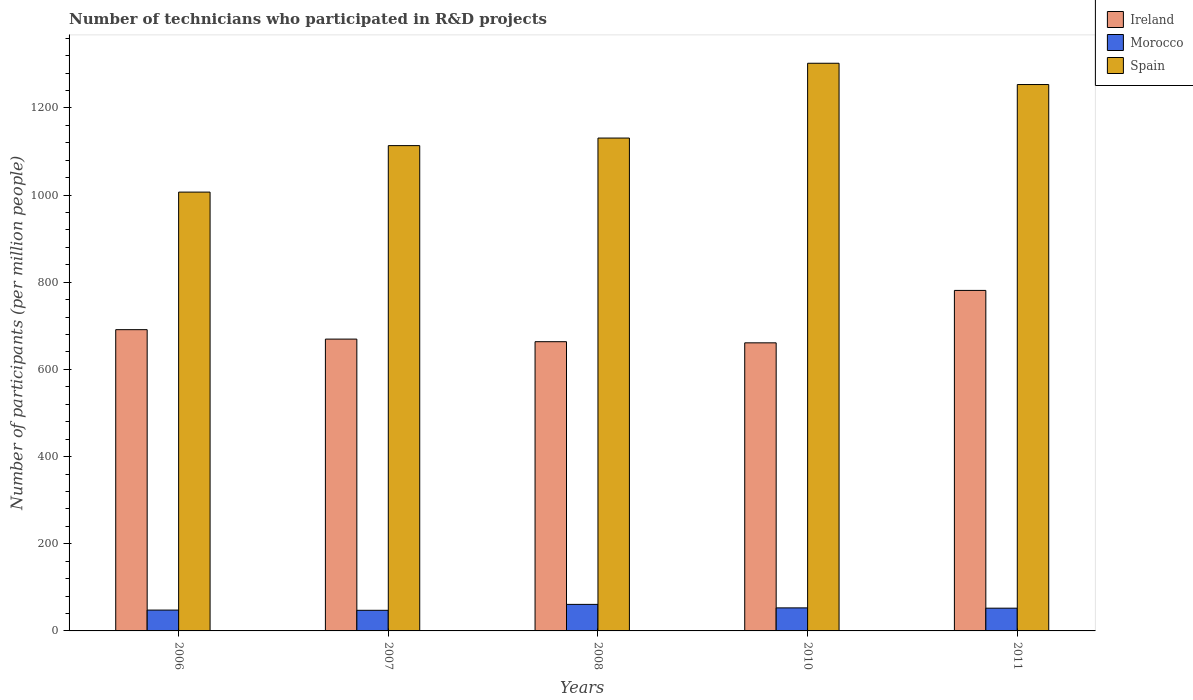How many groups of bars are there?
Provide a succinct answer. 5. How many bars are there on the 5th tick from the left?
Provide a short and direct response. 3. How many bars are there on the 5th tick from the right?
Offer a very short reply. 3. What is the label of the 4th group of bars from the left?
Ensure brevity in your answer.  2010. What is the number of technicians who participated in R&D projects in Spain in 2011?
Offer a terse response. 1253.62. Across all years, what is the maximum number of technicians who participated in R&D projects in Ireland?
Make the answer very short. 781.26. Across all years, what is the minimum number of technicians who participated in R&D projects in Ireland?
Make the answer very short. 660.99. In which year was the number of technicians who participated in R&D projects in Morocco maximum?
Your response must be concise. 2008. In which year was the number of technicians who participated in R&D projects in Spain minimum?
Keep it short and to the point. 2006. What is the total number of technicians who participated in R&D projects in Spain in the graph?
Your answer should be compact. 5807.26. What is the difference between the number of technicians who participated in R&D projects in Ireland in 2006 and that in 2010?
Keep it short and to the point. 30.22. What is the difference between the number of technicians who participated in R&D projects in Ireland in 2007 and the number of technicians who participated in R&D projects in Spain in 2011?
Your answer should be compact. -584.05. What is the average number of technicians who participated in R&D projects in Spain per year?
Your answer should be compact. 1161.45. In the year 2010, what is the difference between the number of technicians who participated in R&D projects in Ireland and number of technicians who participated in R&D projects in Spain?
Make the answer very short. -641.47. What is the ratio of the number of technicians who participated in R&D projects in Ireland in 2007 to that in 2010?
Offer a very short reply. 1.01. Is the number of technicians who participated in R&D projects in Morocco in 2007 less than that in 2008?
Provide a short and direct response. Yes. What is the difference between the highest and the second highest number of technicians who participated in R&D projects in Ireland?
Give a very brief answer. 90.06. What is the difference between the highest and the lowest number of technicians who participated in R&D projects in Spain?
Provide a short and direct response. 295.63. In how many years, is the number of technicians who participated in R&D projects in Spain greater than the average number of technicians who participated in R&D projects in Spain taken over all years?
Offer a very short reply. 2. What does the 2nd bar from the left in 2006 represents?
Provide a short and direct response. Morocco. What does the 3rd bar from the right in 2007 represents?
Your answer should be very brief. Ireland. Is it the case that in every year, the sum of the number of technicians who participated in R&D projects in Morocco and number of technicians who participated in R&D projects in Ireland is greater than the number of technicians who participated in R&D projects in Spain?
Give a very brief answer. No. How many bars are there?
Offer a terse response. 15. How many years are there in the graph?
Your answer should be very brief. 5. Are the values on the major ticks of Y-axis written in scientific E-notation?
Provide a short and direct response. No. Does the graph contain any zero values?
Your answer should be very brief. No. How many legend labels are there?
Keep it short and to the point. 3. How are the legend labels stacked?
Ensure brevity in your answer.  Vertical. What is the title of the graph?
Make the answer very short. Number of technicians who participated in R&D projects. What is the label or title of the X-axis?
Keep it short and to the point. Years. What is the label or title of the Y-axis?
Provide a succinct answer. Number of participants (per million people). What is the Number of participants (per million people) of Ireland in 2006?
Offer a terse response. 691.21. What is the Number of participants (per million people) of Morocco in 2006?
Your answer should be compact. 47.8. What is the Number of participants (per million people) in Spain in 2006?
Offer a very short reply. 1006.83. What is the Number of participants (per million people) in Ireland in 2007?
Ensure brevity in your answer.  669.57. What is the Number of participants (per million people) in Morocco in 2007?
Your answer should be compact. 47.31. What is the Number of participants (per million people) in Spain in 2007?
Make the answer very short. 1113.5. What is the Number of participants (per million people) of Ireland in 2008?
Provide a short and direct response. 663.59. What is the Number of participants (per million people) in Morocco in 2008?
Offer a very short reply. 60.89. What is the Number of participants (per million people) in Spain in 2008?
Your response must be concise. 1130.85. What is the Number of participants (per million people) of Ireland in 2010?
Give a very brief answer. 660.99. What is the Number of participants (per million people) of Morocco in 2010?
Your response must be concise. 52.85. What is the Number of participants (per million people) of Spain in 2010?
Offer a terse response. 1302.46. What is the Number of participants (per million people) of Ireland in 2011?
Offer a terse response. 781.26. What is the Number of participants (per million people) of Morocco in 2011?
Your answer should be compact. 52.16. What is the Number of participants (per million people) in Spain in 2011?
Keep it short and to the point. 1253.62. Across all years, what is the maximum Number of participants (per million people) of Ireland?
Give a very brief answer. 781.26. Across all years, what is the maximum Number of participants (per million people) of Morocco?
Keep it short and to the point. 60.89. Across all years, what is the maximum Number of participants (per million people) in Spain?
Ensure brevity in your answer.  1302.46. Across all years, what is the minimum Number of participants (per million people) in Ireland?
Offer a very short reply. 660.99. Across all years, what is the minimum Number of participants (per million people) in Morocco?
Provide a succinct answer. 47.31. Across all years, what is the minimum Number of participants (per million people) of Spain?
Make the answer very short. 1006.83. What is the total Number of participants (per million people) in Ireland in the graph?
Ensure brevity in your answer.  3466.63. What is the total Number of participants (per million people) in Morocco in the graph?
Your answer should be compact. 261.01. What is the total Number of participants (per million people) of Spain in the graph?
Give a very brief answer. 5807.26. What is the difference between the Number of participants (per million people) in Ireland in 2006 and that in 2007?
Provide a succinct answer. 21.63. What is the difference between the Number of participants (per million people) of Morocco in 2006 and that in 2007?
Ensure brevity in your answer.  0.49. What is the difference between the Number of participants (per million people) of Spain in 2006 and that in 2007?
Provide a succinct answer. -106.67. What is the difference between the Number of participants (per million people) in Ireland in 2006 and that in 2008?
Make the answer very short. 27.61. What is the difference between the Number of participants (per million people) of Morocco in 2006 and that in 2008?
Offer a very short reply. -13.09. What is the difference between the Number of participants (per million people) in Spain in 2006 and that in 2008?
Make the answer very short. -124.02. What is the difference between the Number of participants (per million people) in Ireland in 2006 and that in 2010?
Offer a terse response. 30.22. What is the difference between the Number of participants (per million people) of Morocco in 2006 and that in 2010?
Your response must be concise. -5.05. What is the difference between the Number of participants (per million people) of Spain in 2006 and that in 2010?
Ensure brevity in your answer.  -295.63. What is the difference between the Number of participants (per million people) in Ireland in 2006 and that in 2011?
Provide a short and direct response. -90.06. What is the difference between the Number of participants (per million people) in Morocco in 2006 and that in 2011?
Give a very brief answer. -4.37. What is the difference between the Number of participants (per million people) of Spain in 2006 and that in 2011?
Ensure brevity in your answer.  -246.79. What is the difference between the Number of participants (per million people) in Ireland in 2007 and that in 2008?
Give a very brief answer. 5.98. What is the difference between the Number of participants (per million people) of Morocco in 2007 and that in 2008?
Make the answer very short. -13.59. What is the difference between the Number of participants (per million people) of Spain in 2007 and that in 2008?
Provide a short and direct response. -17.35. What is the difference between the Number of participants (per million people) in Ireland in 2007 and that in 2010?
Your answer should be very brief. 8.59. What is the difference between the Number of participants (per million people) of Morocco in 2007 and that in 2010?
Your answer should be very brief. -5.55. What is the difference between the Number of participants (per million people) in Spain in 2007 and that in 2010?
Give a very brief answer. -188.96. What is the difference between the Number of participants (per million people) of Ireland in 2007 and that in 2011?
Give a very brief answer. -111.69. What is the difference between the Number of participants (per million people) of Morocco in 2007 and that in 2011?
Provide a short and direct response. -4.86. What is the difference between the Number of participants (per million people) in Spain in 2007 and that in 2011?
Provide a succinct answer. -140.12. What is the difference between the Number of participants (per million people) in Ireland in 2008 and that in 2010?
Give a very brief answer. 2.61. What is the difference between the Number of participants (per million people) of Morocco in 2008 and that in 2010?
Keep it short and to the point. 8.04. What is the difference between the Number of participants (per million people) in Spain in 2008 and that in 2010?
Your answer should be very brief. -171.61. What is the difference between the Number of participants (per million people) in Ireland in 2008 and that in 2011?
Your answer should be compact. -117.67. What is the difference between the Number of participants (per million people) in Morocco in 2008 and that in 2011?
Your answer should be compact. 8.73. What is the difference between the Number of participants (per million people) in Spain in 2008 and that in 2011?
Make the answer very short. -122.77. What is the difference between the Number of participants (per million people) in Ireland in 2010 and that in 2011?
Ensure brevity in your answer.  -120.28. What is the difference between the Number of participants (per million people) of Morocco in 2010 and that in 2011?
Offer a terse response. 0.69. What is the difference between the Number of participants (per million people) of Spain in 2010 and that in 2011?
Ensure brevity in your answer.  48.84. What is the difference between the Number of participants (per million people) of Ireland in 2006 and the Number of participants (per million people) of Morocco in 2007?
Your response must be concise. 643.9. What is the difference between the Number of participants (per million people) of Ireland in 2006 and the Number of participants (per million people) of Spain in 2007?
Provide a short and direct response. -422.3. What is the difference between the Number of participants (per million people) in Morocco in 2006 and the Number of participants (per million people) in Spain in 2007?
Keep it short and to the point. -1065.7. What is the difference between the Number of participants (per million people) in Ireland in 2006 and the Number of participants (per million people) in Morocco in 2008?
Keep it short and to the point. 630.31. What is the difference between the Number of participants (per million people) of Ireland in 2006 and the Number of participants (per million people) of Spain in 2008?
Give a very brief answer. -439.64. What is the difference between the Number of participants (per million people) in Morocco in 2006 and the Number of participants (per million people) in Spain in 2008?
Your response must be concise. -1083.05. What is the difference between the Number of participants (per million people) of Ireland in 2006 and the Number of participants (per million people) of Morocco in 2010?
Your answer should be compact. 638.35. What is the difference between the Number of participants (per million people) of Ireland in 2006 and the Number of participants (per million people) of Spain in 2010?
Your answer should be very brief. -611.25. What is the difference between the Number of participants (per million people) of Morocco in 2006 and the Number of participants (per million people) of Spain in 2010?
Provide a short and direct response. -1254.66. What is the difference between the Number of participants (per million people) in Ireland in 2006 and the Number of participants (per million people) in Morocco in 2011?
Ensure brevity in your answer.  639.04. What is the difference between the Number of participants (per million people) in Ireland in 2006 and the Number of participants (per million people) in Spain in 2011?
Your response must be concise. -562.41. What is the difference between the Number of participants (per million people) of Morocco in 2006 and the Number of participants (per million people) of Spain in 2011?
Provide a short and direct response. -1205.82. What is the difference between the Number of participants (per million people) of Ireland in 2007 and the Number of participants (per million people) of Morocco in 2008?
Ensure brevity in your answer.  608.68. What is the difference between the Number of participants (per million people) in Ireland in 2007 and the Number of participants (per million people) in Spain in 2008?
Provide a short and direct response. -461.27. What is the difference between the Number of participants (per million people) of Morocco in 2007 and the Number of participants (per million people) of Spain in 2008?
Provide a short and direct response. -1083.54. What is the difference between the Number of participants (per million people) of Ireland in 2007 and the Number of participants (per million people) of Morocco in 2010?
Your response must be concise. 616.72. What is the difference between the Number of participants (per million people) of Ireland in 2007 and the Number of participants (per million people) of Spain in 2010?
Ensure brevity in your answer.  -632.89. What is the difference between the Number of participants (per million people) in Morocco in 2007 and the Number of participants (per million people) in Spain in 2010?
Ensure brevity in your answer.  -1255.16. What is the difference between the Number of participants (per million people) in Ireland in 2007 and the Number of participants (per million people) in Morocco in 2011?
Your answer should be very brief. 617.41. What is the difference between the Number of participants (per million people) of Ireland in 2007 and the Number of participants (per million people) of Spain in 2011?
Give a very brief answer. -584.05. What is the difference between the Number of participants (per million people) in Morocco in 2007 and the Number of participants (per million people) in Spain in 2011?
Provide a succinct answer. -1206.31. What is the difference between the Number of participants (per million people) of Ireland in 2008 and the Number of participants (per million people) of Morocco in 2010?
Provide a succinct answer. 610.74. What is the difference between the Number of participants (per million people) of Ireland in 2008 and the Number of participants (per million people) of Spain in 2010?
Offer a terse response. -638.87. What is the difference between the Number of participants (per million people) of Morocco in 2008 and the Number of participants (per million people) of Spain in 2010?
Give a very brief answer. -1241.57. What is the difference between the Number of participants (per million people) in Ireland in 2008 and the Number of participants (per million people) in Morocco in 2011?
Offer a terse response. 611.43. What is the difference between the Number of participants (per million people) in Ireland in 2008 and the Number of participants (per million people) in Spain in 2011?
Make the answer very short. -590.02. What is the difference between the Number of participants (per million people) of Morocco in 2008 and the Number of participants (per million people) of Spain in 2011?
Keep it short and to the point. -1192.73. What is the difference between the Number of participants (per million people) in Ireland in 2010 and the Number of participants (per million people) in Morocco in 2011?
Your answer should be very brief. 608.82. What is the difference between the Number of participants (per million people) of Ireland in 2010 and the Number of participants (per million people) of Spain in 2011?
Your answer should be very brief. -592.63. What is the difference between the Number of participants (per million people) of Morocco in 2010 and the Number of participants (per million people) of Spain in 2011?
Provide a succinct answer. -1200.77. What is the average Number of participants (per million people) of Ireland per year?
Keep it short and to the point. 693.33. What is the average Number of participants (per million people) in Morocco per year?
Your answer should be very brief. 52.2. What is the average Number of participants (per million people) in Spain per year?
Offer a very short reply. 1161.45. In the year 2006, what is the difference between the Number of participants (per million people) in Ireland and Number of participants (per million people) in Morocco?
Keep it short and to the point. 643.41. In the year 2006, what is the difference between the Number of participants (per million people) in Ireland and Number of participants (per million people) in Spain?
Your answer should be compact. -315.62. In the year 2006, what is the difference between the Number of participants (per million people) of Morocco and Number of participants (per million people) of Spain?
Your answer should be very brief. -959.03. In the year 2007, what is the difference between the Number of participants (per million people) of Ireland and Number of participants (per million people) of Morocco?
Offer a very short reply. 622.27. In the year 2007, what is the difference between the Number of participants (per million people) of Ireland and Number of participants (per million people) of Spain?
Keep it short and to the point. -443.93. In the year 2007, what is the difference between the Number of participants (per million people) in Morocco and Number of participants (per million people) in Spain?
Ensure brevity in your answer.  -1066.2. In the year 2008, what is the difference between the Number of participants (per million people) of Ireland and Number of participants (per million people) of Morocco?
Ensure brevity in your answer.  602.7. In the year 2008, what is the difference between the Number of participants (per million people) of Ireland and Number of participants (per million people) of Spain?
Your answer should be very brief. -467.25. In the year 2008, what is the difference between the Number of participants (per million people) of Morocco and Number of participants (per million people) of Spain?
Your answer should be very brief. -1069.96. In the year 2010, what is the difference between the Number of participants (per million people) in Ireland and Number of participants (per million people) in Morocco?
Keep it short and to the point. 608.13. In the year 2010, what is the difference between the Number of participants (per million people) of Ireland and Number of participants (per million people) of Spain?
Ensure brevity in your answer.  -641.47. In the year 2010, what is the difference between the Number of participants (per million people) in Morocco and Number of participants (per million people) in Spain?
Offer a terse response. -1249.61. In the year 2011, what is the difference between the Number of participants (per million people) of Ireland and Number of participants (per million people) of Morocco?
Give a very brief answer. 729.1. In the year 2011, what is the difference between the Number of participants (per million people) of Ireland and Number of participants (per million people) of Spain?
Keep it short and to the point. -472.35. In the year 2011, what is the difference between the Number of participants (per million people) of Morocco and Number of participants (per million people) of Spain?
Provide a succinct answer. -1201.45. What is the ratio of the Number of participants (per million people) in Ireland in 2006 to that in 2007?
Ensure brevity in your answer.  1.03. What is the ratio of the Number of participants (per million people) of Morocco in 2006 to that in 2007?
Make the answer very short. 1.01. What is the ratio of the Number of participants (per million people) of Spain in 2006 to that in 2007?
Make the answer very short. 0.9. What is the ratio of the Number of participants (per million people) in Ireland in 2006 to that in 2008?
Offer a terse response. 1.04. What is the ratio of the Number of participants (per million people) of Morocco in 2006 to that in 2008?
Your answer should be compact. 0.79. What is the ratio of the Number of participants (per million people) of Spain in 2006 to that in 2008?
Offer a terse response. 0.89. What is the ratio of the Number of participants (per million people) of Ireland in 2006 to that in 2010?
Keep it short and to the point. 1.05. What is the ratio of the Number of participants (per million people) of Morocco in 2006 to that in 2010?
Your answer should be compact. 0.9. What is the ratio of the Number of participants (per million people) of Spain in 2006 to that in 2010?
Offer a terse response. 0.77. What is the ratio of the Number of participants (per million people) in Ireland in 2006 to that in 2011?
Your response must be concise. 0.88. What is the ratio of the Number of participants (per million people) of Morocco in 2006 to that in 2011?
Offer a terse response. 0.92. What is the ratio of the Number of participants (per million people) of Spain in 2006 to that in 2011?
Offer a terse response. 0.8. What is the ratio of the Number of participants (per million people) of Ireland in 2007 to that in 2008?
Your answer should be compact. 1.01. What is the ratio of the Number of participants (per million people) of Morocco in 2007 to that in 2008?
Your answer should be compact. 0.78. What is the ratio of the Number of participants (per million people) in Spain in 2007 to that in 2008?
Give a very brief answer. 0.98. What is the ratio of the Number of participants (per million people) of Ireland in 2007 to that in 2010?
Your answer should be very brief. 1.01. What is the ratio of the Number of participants (per million people) of Morocco in 2007 to that in 2010?
Your answer should be very brief. 0.9. What is the ratio of the Number of participants (per million people) in Spain in 2007 to that in 2010?
Provide a succinct answer. 0.85. What is the ratio of the Number of participants (per million people) in Ireland in 2007 to that in 2011?
Offer a very short reply. 0.86. What is the ratio of the Number of participants (per million people) in Morocco in 2007 to that in 2011?
Make the answer very short. 0.91. What is the ratio of the Number of participants (per million people) in Spain in 2007 to that in 2011?
Ensure brevity in your answer.  0.89. What is the ratio of the Number of participants (per million people) of Morocco in 2008 to that in 2010?
Offer a very short reply. 1.15. What is the ratio of the Number of participants (per million people) of Spain in 2008 to that in 2010?
Provide a short and direct response. 0.87. What is the ratio of the Number of participants (per million people) of Ireland in 2008 to that in 2011?
Offer a terse response. 0.85. What is the ratio of the Number of participants (per million people) in Morocco in 2008 to that in 2011?
Offer a very short reply. 1.17. What is the ratio of the Number of participants (per million people) in Spain in 2008 to that in 2011?
Make the answer very short. 0.9. What is the ratio of the Number of participants (per million people) of Ireland in 2010 to that in 2011?
Your answer should be very brief. 0.85. What is the ratio of the Number of participants (per million people) in Morocco in 2010 to that in 2011?
Your response must be concise. 1.01. What is the ratio of the Number of participants (per million people) of Spain in 2010 to that in 2011?
Offer a very short reply. 1.04. What is the difference between the highest and the second highest Number of participants (per million people) of Ireland?
Your response must be concise. 90.06. What is the difference between the highest and the second highest Number of participants (per million people) in Morocco?
Provide a succinct answer. 8.04. What is the difference between the highest and the second highest Number of participants (per million people) of Spain?
Your answer should be compact. 48.84. What is the difference between the highest and the lowest Number of participants (per million people) in Ireland?
Ensure brevity in your answer.  120.28. What is the difference between the highest and the lowest Number of participants (per million people) in Morocco?
Offer a very short reply. 13.59. What is the difference between the highest and the lowest Number of participants (per million people) in Spain?
Provide a short and direct response. 295.63. 